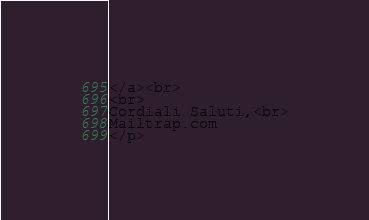Convert code to text. <code><loc_0><loc_0><loc_500><loc_500><_PHP_></a><br>
<br>
Cordiali Saluti,<br>
Mailtrap.com
</p> </code> 